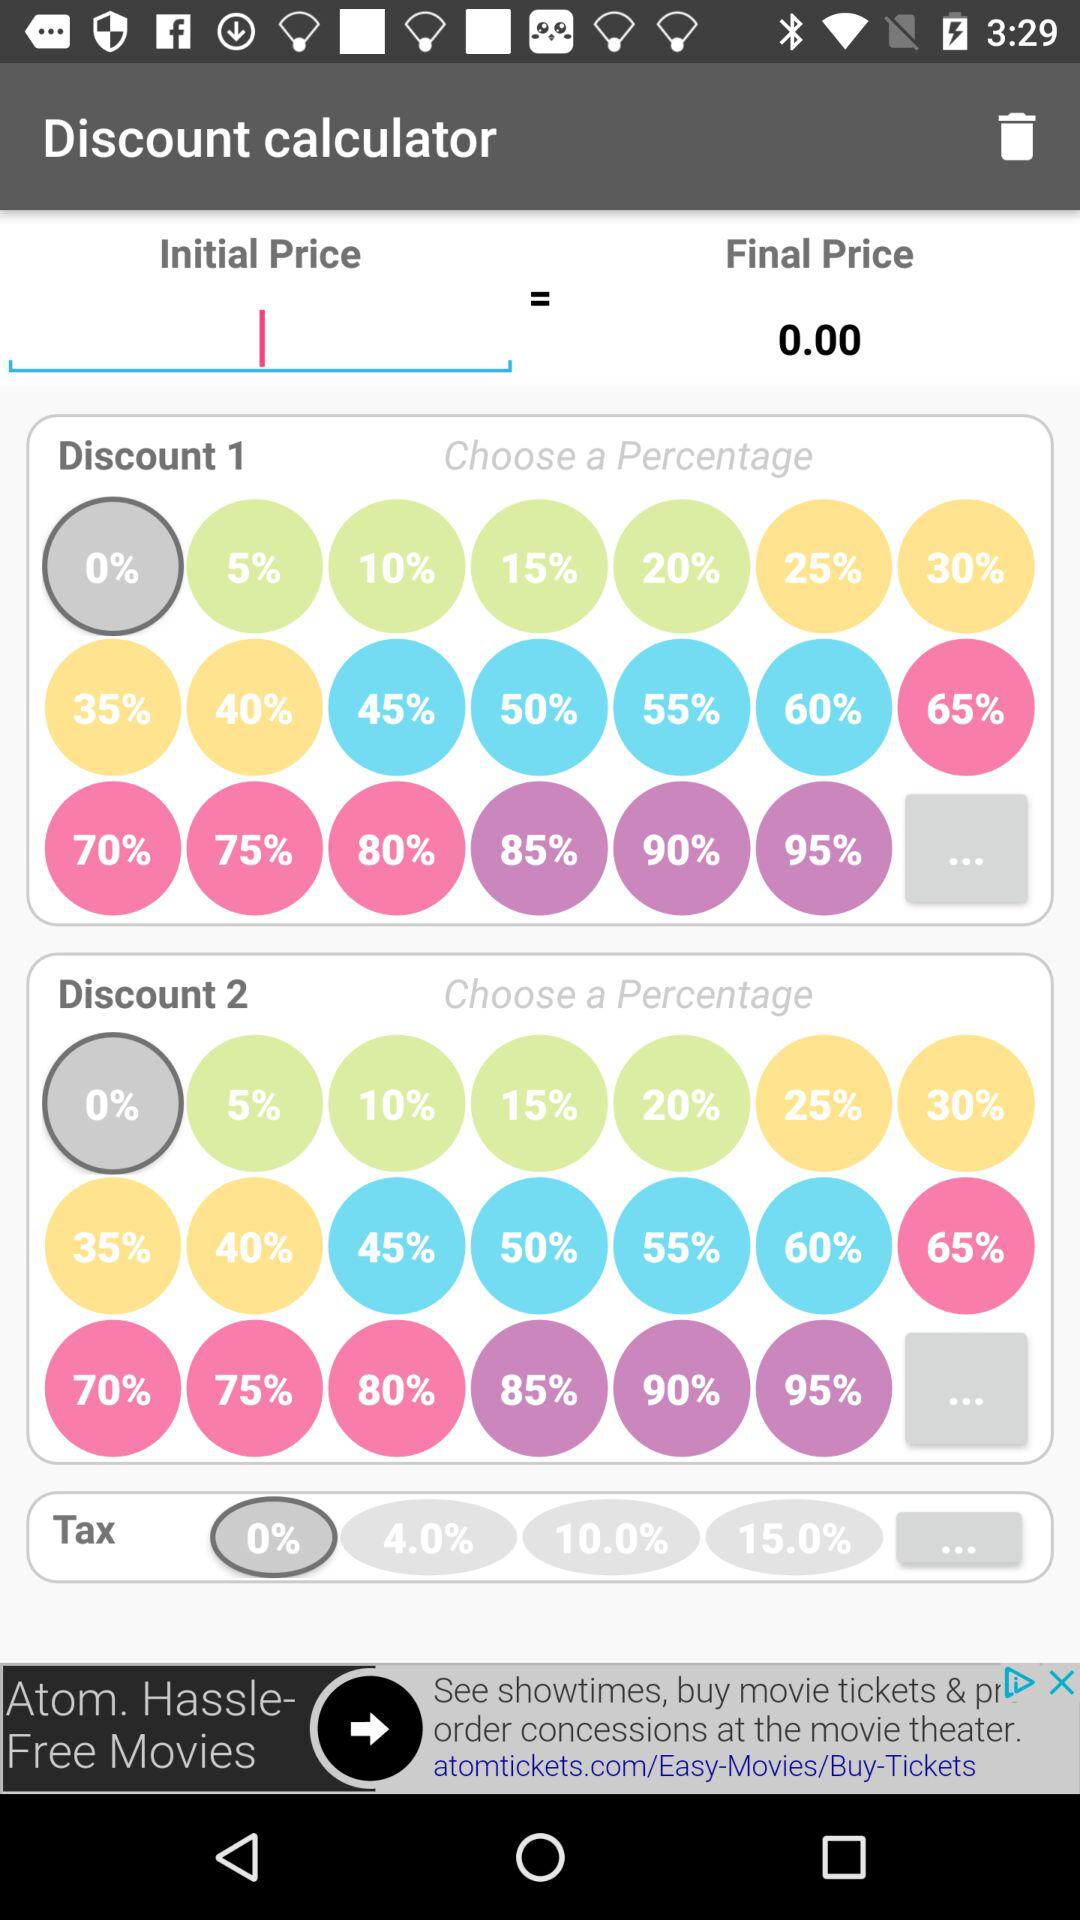What's the different percentage of the tax? The different percentages are 0, 4, 10 and 15. 